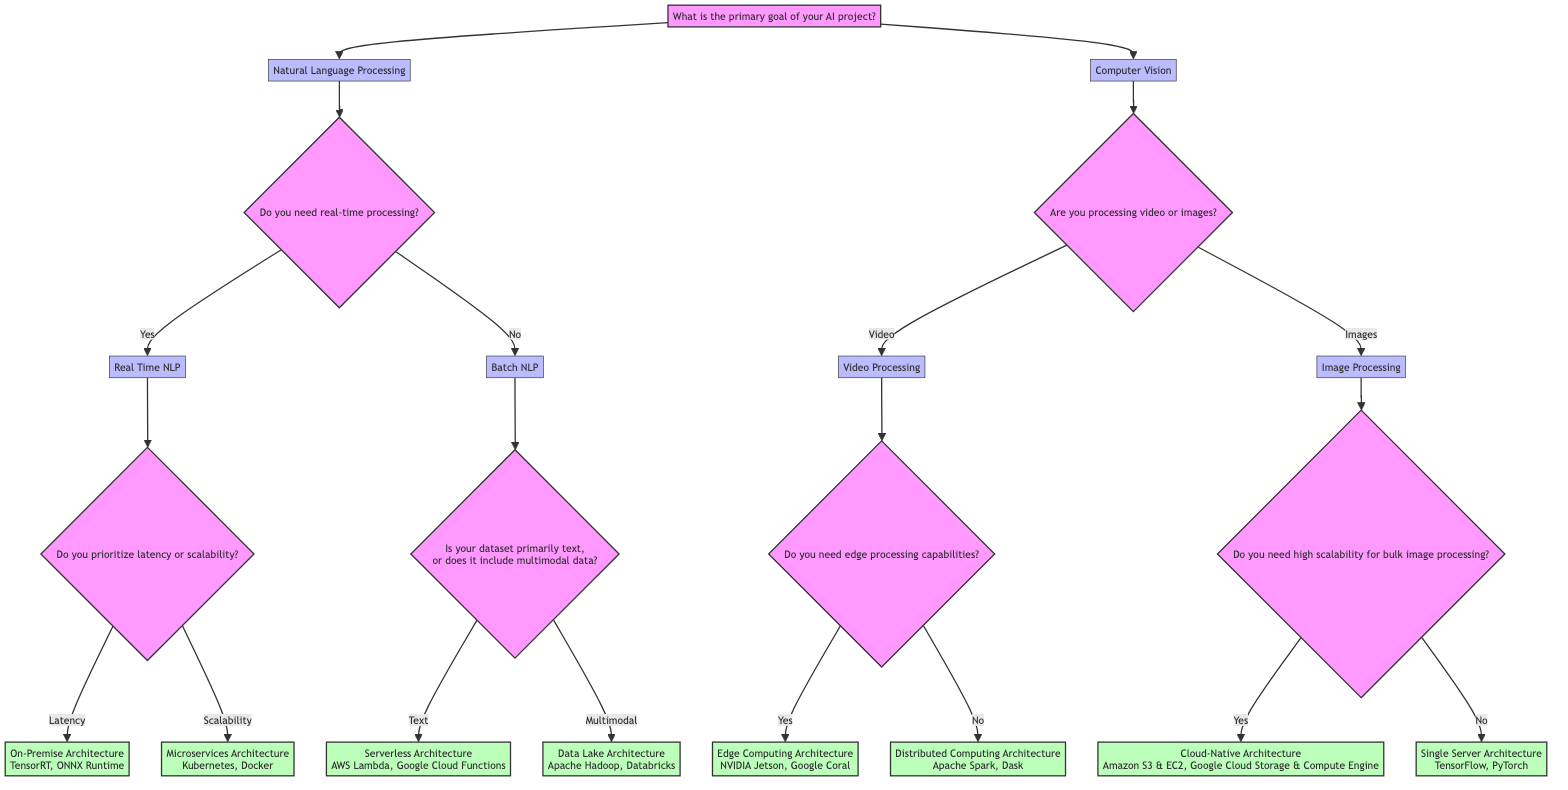What is the primary goal of the AI project in the first question? The first question in the diagram asks, "What is the primary goal of your AI project?". According to the decision structure, the two possible answers are "Natural Language Processing" or "Computer Vision".
Answer: Natural Language Processing or Computer Vision How many choices do you have after answering the first question? After answering the first question, the choices are "Natural Language Processing" and "Computer Vision," which gives a total of 2 choices.
Answer: 2 What architecture is suggested if you need real-time processing and prioritize latency? If you select "Real Time NLP" and prioritize latency, then the diagram indicates "On-Premise Architecture" as the suggested architecture.
Answer: On-Premise Architecture What is indicated if the dataset is primarily text in a Batch NLP scenario? In a Batch NLP scenario, if the dataset is primarily text, the diagram leads to "Serverless Architecture," which suggests that users can adopt either AWS Lambda or Google Cloud Functions.
Answer: Serverless Architecture Are the edge processing capabilities required in Video Processing? If you are processing video, the question in the diagram asks whether edge processing capabilities are needed. Depending on the response, the choices are "Yes" for Edge Computing Architecture or "No" for Distributed Computing Architecture.
Answer: Yes or No How many nodes are there in the Computer Vision section? In the Computer Vision section, there are 4 nodes: "Video Processing", "Images", "Do you need edge processing capabilities?", and the two outcomes of that question, leading to "Edge Computing Architecture" and "Distributed Computing Architecture." Thus, there are 4 nodes in total.
Answer: 4 What do you need for high scalability in bulk image processing? The decision tree states that for Image Processing, if high scalability is needed for bulk image processing, then "Cloud-Native Architecture" is the chosen path, indicating usage such as Amazon S3 and EC2 or Google Cloud Storage and Compute Engine.
Answer: Cloud-Native Architecture If you want to implement a decision tree, how many outcomes can you derive from "Do you need real-time processing?" This question offers two outcomes: "Yes," which leads to latency or scalability, and "No," which branches into text or multimodal data. Therefore, there are a total of 4 distinct outcomes from this node.
Answer: 4 